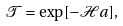Convert formula to latex. <formula><loc_0><loc_0><loc_500><loc_500>\mathcal { T } = \exp [ - \mathcal { H } a ] ,</formula> 